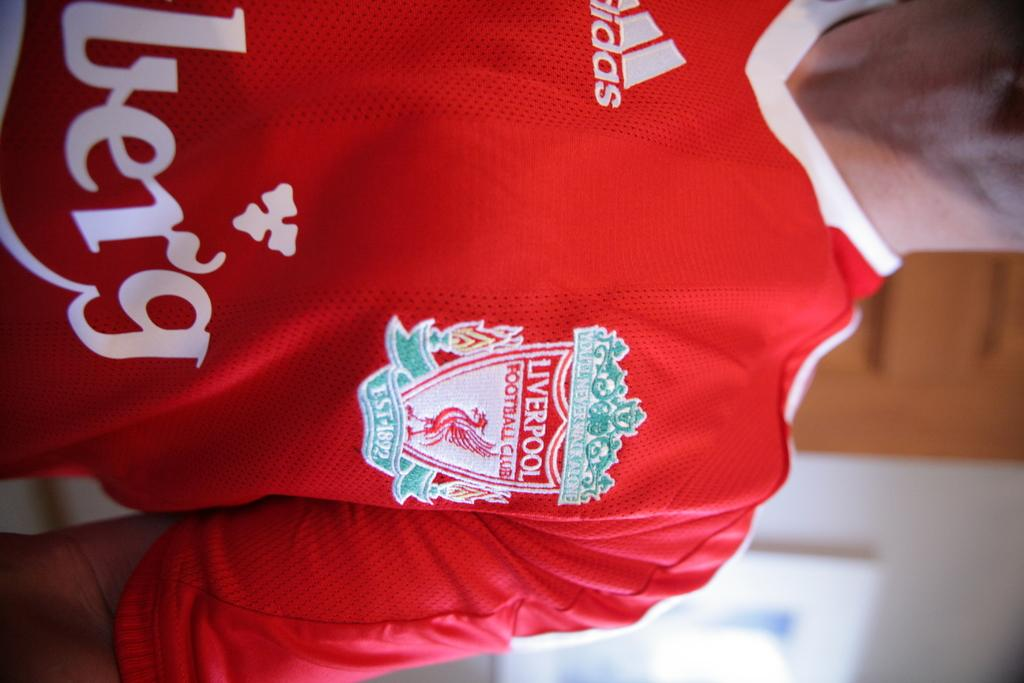<image>
Summarize the visual content of the image. Person wearing a jersey for Liverpool sponsored by Adidas. 